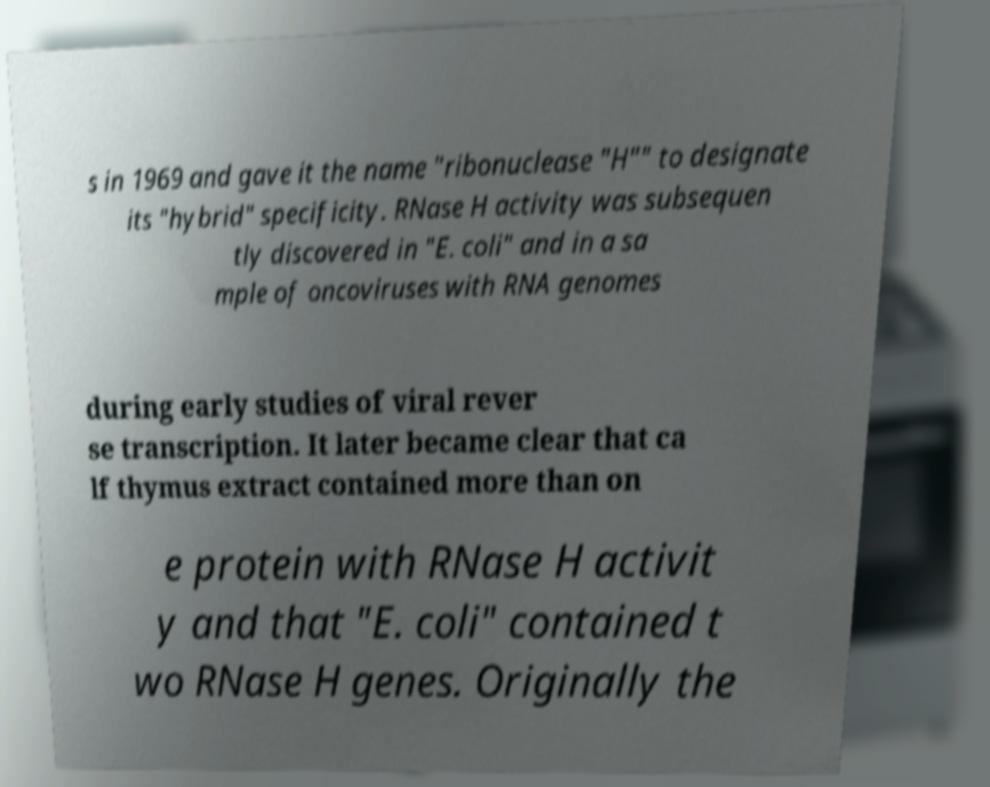I need the written content from this picture converted into text. Can you do that? s in 1969 and gave it the name "ribonuclease "H"" to designate its "hybrid" specificity. RNase H activity was subsequen tly discovered in "E. coli" and in a sa mple of oncoviruses with RNA genomes during early studies of viral rever se transcription. It later became clear that ca lf thymus extract contained more than on e protein with RNase H activit y and that "E. coli" contained t wo RNase H genes. Originally the 